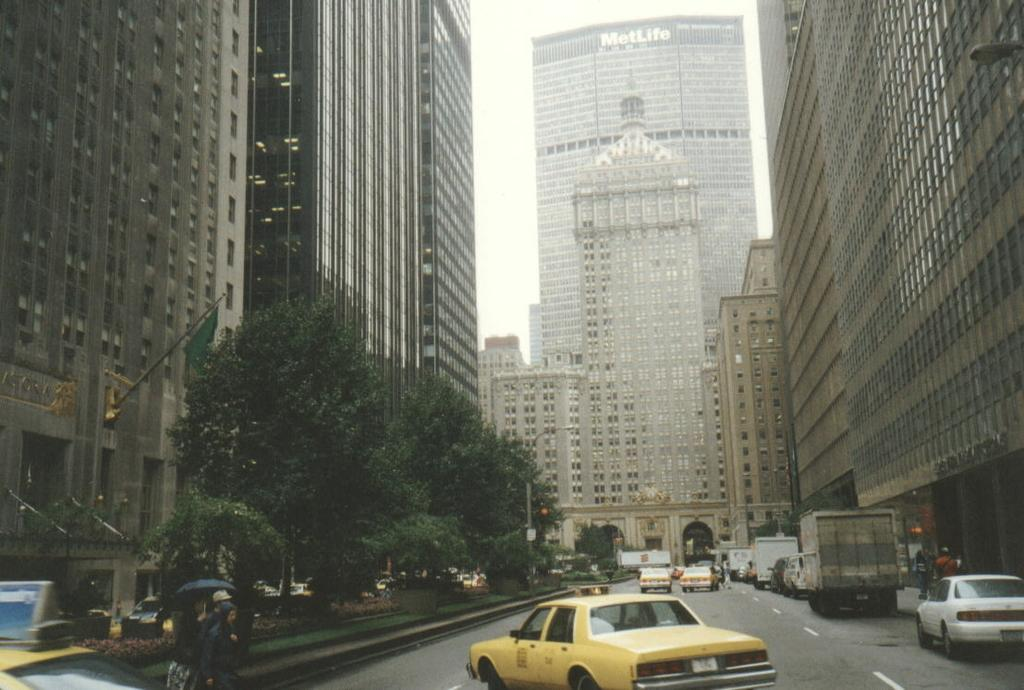Provide a one-sentence caption for the provided image. a taxi can in New York with a sign at the top of it and a Metlife building. 